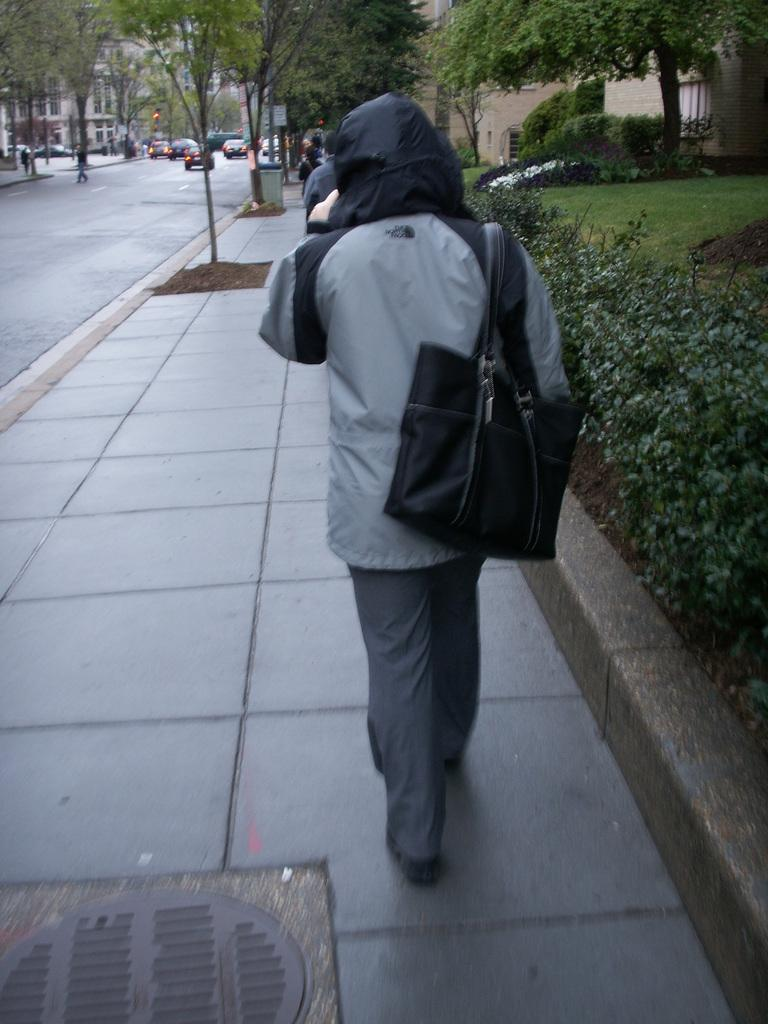Who or what is the main subject in the image? There is a person in the image. What is the person wearing in the image? The person is wearing a handbag. What can be seen in the background of the image? Trees, cars, and a building are visible in the background of the image. What type of pipe is the person holding in the image? There is no pipe present in the image. How many hearts can be seen in the image? There are no hearts visible in the image. 